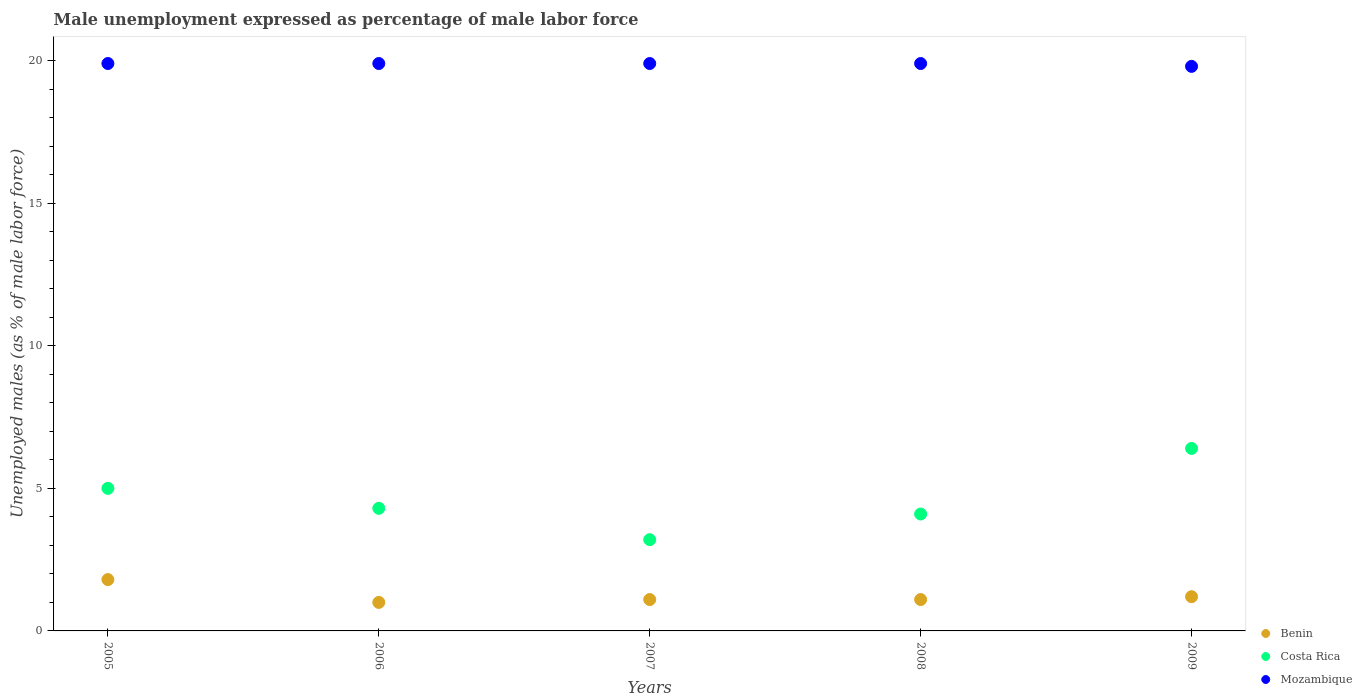How many different coloured dotlines are there?
Your answer should be very brief. 3. What is the unemployment in males in in Benin in 2009?
Your answer should be compact. 1.2. Across all years, what is the maximum unemployment in males in in Mozambique?
Your response must be concise. 19.9. In which year was the unemployment in males in in Mozambique maximum?
Your answer should be compact. 2005. What is the total unemployment in males in in Benin in the graph?
Give a very brief answer. 6.2. What is the difference between the unemployment in males in in Benin in 2005 and that in 2006?
Your response must be concise. 0.8. What is the difference between the unemployment in males in in Mozambique in 2007 and the unemployment in males in in Benin in 2009?
Keep it short and to the point. 18.7. What is the average unemployment in males in in Mozambique per year?
Keep it short and to the point. 19.88. In the year 2005, what is the difference between the unemployment in males in in Mozambique and unemployment in males in in Benin?
Provide a succinct answer. 18.1. What is the ratio of the unemployment in males in in Costa Rica in 2005 to that in 2007?
Provide a succinct answer. 1.56. What is the difference between the highest and the second highest unemployment in males in in Benin?
Give a very brief answer. 0.6. What is the difference between the highest and the lowest unemployment in males in in Mozambique?
Provide a succinct answer. 0.1. In how many years, is the unemployment in males in in Costa Rica greater than the average unemployment in males in in Costa Rica taken over all years?
Give a very brief answer. 2. Is the sum of the unemployment in males in in Benin in 2005 and 2007 greater than the maximum unemployment in males in in Mozambique across all years?
Keep it short and to the point. No. Is it the case that in every year, the sum of the unemployment in males in in Costa Rica and unemployment in males in in Benin  is greater than the unemployment in males in in Mozambique?
Your response must be concise. No. Does the unemployment in males in in Costa Rica monotonically increase over the years?
Keep it short and to the point. No. How many dotlines are there?
Keep it short and to the point. 3. How many years are there in the graph?
Your response must be concise. 5. What is the difference between two consecutive major ticks on the Y-axis?
Offer a terse response. 5. Are the values on the major ticks of Y-axis written in scientific E-notation?
Ensure brevity in your answer.  No. Does the graph contain any zero values?
Your response must be concise. No. Does the graph contain grids?
Your answer should be compact. No. How are the legend labels stacked?
Ensure brevity in your answer.  Vertical. What is the title of the graph?
Give a very brief answer. Male unemployment expressed as percentage of male labor force. Does "Uzbekistan" appear as one of the legend labels in the graph?
Your answer should be very brief. No. What is the label or title of the X-axis?
Provide a succinct answer. Years. What is the label or title of the Y-axis?
Your answer should be very brief. Unemployed males (as % of male labor force). What is the Unemployed males (as % of male labor force) in Benin in 2005?
Ensure brevity in your answer.  1.8. What is the Unemployed males (as % of male labor force) in Mozambique in 2005?
Provide a succinct answer. 19.9. What is the Unemployed males (as % of male labor force) in Benin in 2006?
Offer a terse response. 1. What is the Unemployed males (as % of male labor force) in Costa Rica in 2006?
Provide a succinct answer. 4.3. What is the Unemployed males (as % of male labor force) of Mozambique in 2006?
Your answer should be compact. 19.9. What is the Unemployed males (as % of male labor force) in Benin in 2007?
Keep it short and to the point. 1.1. What is the Unemployed males (as % of male labor force) in Costa Rica in 2007?
Your response must be concise. 3.2. What is the Unemployed males (as % of male labor force) of Mozambique in 2007?
Make the answer very short. 19.9. What is the Unemployed males (as % of male labor force) in Benin in 2008?
Ensure brevity in your answer.  1.1. What is the Unemployed males (as % of male labor force) of Costa Rica in 2008?
Give a very brief answer. 4.1. What is the Unemployed males (as % of male labor force) in Mozambique in 2008?
Provide a succinct answer. 19.9. What is the Unemployed males (as % of male labor force) of Benin in 2009?
Offer a very short reply. 1.2. What is the Unemployed males (as % of male labor force) of Costa Rica in 2009?
Offer a very short reply. 6.4. What is the Unemployed males (as % of male labor force) in Mozambique in 2009?
Offer a terse response. 19.8. Across all years, what is the maximum Unemployed males (as % of male labor force) in Benin?
Provide a short and direct response. 1.8. Across all years, what is the maximum Unemployed males (as % of male labor force) of Costa Rica?
Provide a succinct answer. 6.4. Across all years, what is the maximum Unemployed males (as % of male labor force) of Mozambique?
Offer a very short reply. 19.9. Across all years, what is the minimum Unemployed males (as % of male labor force) of Benin?
Offer a terse response. 1. Across all years, what is the minimum Unemployed males (as % of male labor force) of Costa Rica?
Offer a very short reply. 3.2. Across all years, what is the minimum Unemployed males (as % of male labor force) of Mozambique?
Your response must be concise. 19.8. What is the total Unemployed males (as % of male labor force) of Benin in the graph?
Provide a succinct answer. 6.2. What is the total Unemployed males (as % of male labor force) in Mozambique in the graph?
Offer a very short reply. 99.4. What is the difference between the Unemployed males (as % of male labor force) in Benin in 2005 and that in 2006?
Ensure brevity in your answer.  0.8. What is the difference between the Unemployed males (as % of male labor force) in Costa Rica in 2005 and that in 2006?
Make the answer very short. 0.7. What is the difference between the Unemployed males (as % of male labor force) of Mozambique in 2005 and that in 2006?
Offer a very short reply. 0. What is the difference between the Unemployed males (as % of male labor force) of Benin in 2005 and that in 2009?
Ensure brevity in your answer.  0.6. What is the difference between the Unemployed males (as % of male labor force) in Costa Rica in 2005 and that in 2009?
Keep it short and to the point. -1.4. What is the difference between the Unemployed males (as % of male labor force) of Benin in 2006 and that in 2007?
Offer a terse response. -0.1. What is the difference between the Unemployed males (as % of male labor force) in Costa Rica in 2006 and that in 2007?
Give a very brief answer. 1.1. What is the difference between the Unemployed males (as % of male labor force) of Mozambique in 2006 and that in 2007?
Give a very brief answer. 0. What is the difference between the Unemployed males (as % of male labor force) in Benin in 2006 and that in 2008?
Make the answer very short. -0.1. What is the difference between the Unemployed males (as % of male labor force) in Costa Rica in 2006 and that in 2008?
Ensure brevity in your answer.  0.2. What is the difference between the Unemployed males (as % of male labor force) of Benin in 2006 and that in 2009?
Provide a short and direct response. -0.2. What is the difference between the Unemployed males (as % of male labor force) of Costa Rica in 2006 and that in 2009?
Provide a succinct answer. -2.1. What is the difference between the Unemployed males (as % of male labor force) in Benin in 2007 and that in 2008?
Offer a terse response. 0. What is the difference between the Unemployed males (as % of male labor force) of Mozambique in 2007 and that in 2009?
Offer a very short reply. 0.1. What is the difference between the Unemployed males (as % of male labor force) in Mozambique in 2008 and that in 2009?
Offer a very short reply. 0.1. What is the difference between the Unemployed males (as % of male labor force) in Benin in 2005 and the Unemployed males (as % of male labor force) in Costa Rica in 2006?
Provide a succinct answer. -2.5. What is the difference between the Unemployed males (as % of male labor force) in Benin in 2005 and the Unemployed males (as % of male labor force) in Mozambique in 2006?
Provide a short and direct response. -18.1. What is the difference between the Unemployed males (as % of male labor force) of Costa Rica in 2005 and the Unemployed males (as % of male labor force) of Mozambique in 2006?
Your answer should be compact. -14.9. What is the difference between the Unemployed males (as % of male labor force) in Benin in 2005 and the Unemployed males (as % of male labor force) in Costa Rica in 2007?
Keep it short and to the point. -1.4. What is the difference between the Unemployed males (as % of male labor force) in Benin in 2005 and the Unemployed males (as % of male labor force) in Mozambique in 2007?
Provide a short and direct response. -18.1. What is the difference between the Unemployed males (as % of male labor force) in Costa Rica in 2005 and the Unemployed males (as % of male labor force) in Mozambique in 2007?
Offer a terse response. -14.9. What is the difference between the Unemployed males (as % of male labor force) of Benin in 2005 and the Unemployed males (as % of male labor force) of Mozambique in 2008?
Your answer should be very brief. -18.1. What is the difference between the Unemployed males (as % of male labor force) in Costa Rica in 2005 and the Unemployed males (as % of male labor force) in Mozambique in 2008?
Ensure brevity in your answer.  -14.9. What is the difference between the Unemployed males (as % of male labor force) of Benin in 2005 and the Unemployed males (as % of male labor force) of Costa Rica in 2009?
Your response must be concise. -4.6. What is the difference between the Unemployed males (as % of male labor force) of Costa Rica in 2005 and the Unemployed males (as % of male labor force) of Mozambique in 2009?
Provide a succinct answer. -14.8. What is the difference between the Unemployed males (as % of male labor force) in Benin in 2006 and the Unemployed males (as % of male labor force) in Costa Rica in 2007?
Give a very brief answer. -2.2. What is the difference between the Unemployed males (as % of male labor force) of Benin in 2006 and the Unemployed males (as % of male labor force) of Mozambique in 2007?
Ensure brevity in your answer.  -18.9. What is the difference between the Unemployed males (as % of male labor force) of Costa Rica in 2006 and the Unemployed males (as % of male labor force) of Mozambique in 2007?
Provide a short and direct response. -15.6. What is the difference between the Unemployed males (as % of male labor force) in Benin in 2006 and the Unemployed males (as % of male labor force) in Costa Rica in 2008?
Give a very brief answer. -3.1. What is the difference between the Unemployed males (as % of male labor force) of Benin in 2006 and the Unemployed males (as % of male labor force) of Mozambique in 2008?
Your answer should be very brief. -18.9. What is the difference between the Unemployed males (as % of male labor force) in Costa Rica in 2006 and the Unemployed males (as % of male labor force) in Mozambique in 2008?
Give a very brief answer. -15.6. What is the difference between the Unemployed males (as % of male labor force) of Benin in 2006 and the Unemployed males (as % of male labor force) of Mozambique in 2009?
Provide a short and direct response. -18.8. What is the difference between the Unemployed males (as % of male labor force) in Costa Rica in 2006 and the Unemployed males (as % of male labor force) in Mozambique in 2009?
Give a very brief answer. -15.5. What is the difference between the Unemployed males (as % of male labor force) of Benin in 2007 and the Unemployed males (as % of male labor force) of Costa Rica in 2008?
Ensure brevity in your answer.  -3. What is the difference between the Unemployed males (as % of male labor force) of Benin in 2007 and the Unemployed males (as % of male labor force) of Mozambique in 2008?
Your answer should be very brief. -18.8. What is the difference between the Unemployed males (as % of male labor force) in Costa Rica in 2007 and the Unemployed males (as % of male labor force) in Mozambique in 2008?
Provide a succinct answer. -16.7. What is the difference between the Unemployed males (as % of male labor force) in Benin in 2007 and the Unemployed males (as % of male labor force) in Mozambique in 2009?
Give a very brief answer. -18.7. What is the difference between the Unemployed males (as % of male labor force) of Costa Rica in 2007 and the Unemployed males (as % of male labor force) of Mozambique in 2009?
Keep it short and to the point. -16.6. What is the difference between the Unemployed males (as % of male labor force) in Benin in 2008 and the Unemployed males (as % of male labor force) in Costa Rica in 2009?
Provide a short and direct response. -5.3. What is the difference between the Unemployed males (as % of male labor force) in Benin in 2008 and the Unemployed males (as % of male labor force) in Mozambique in 2009?
Your response must be concise. -18.7. What is the difference between the Unemployed males (as % of male labor force) of Costa Rica in 2008 and the Unemployed males (as % of male labor force) of Mozambique in 2009?
Make the answer very short. -15.7. What is the average Unemployed males (as % of male labor force) of Benin per year?
Your answer should be compact. 1.24. What is the average Unemployed males (as % of male labor force) in Mozambique per year?
Offer a terse response. 19.88. In the year 2005, what is the difference between the Unemployed males (as % of male labor force) of Benin and Unemployed males (as % of male labor force) of Mozambique?
Your answer should be compact. -18.1. In the year 2005, what is the difference between the Unemployed males (as % of male labor force) of Costa Rica and Unemployed males (as % of male labor force) of Mozambique?
Your response must be concise. -14.9. In the year 2006, what is the difference between the Unemployed males (as % of male labor force) in Benin and Unemployed males (as % of male labor force) in Mozambique?
Offer a very short reply. -18.9. In the year 2006, what is the difference between the Unemployed males (as % of male labor force) of Costa Rica and Unemployed males (as % of male labor force) of Mozambique?
Offer a very short reply. -15.6. In the year 2007, what is the difference between the Unemployed males (as % of male labor force) of Benin and Unemployed males (as % of male labor force) of Costa Rica?
Provide a succinct answer. -2.1. In the year 2007, what is the difference between the Unemployed males (as % of male labor force) in Benin and Unemployed males (as % of male labor force) in Mozambique?
Your answer should be very brief. -18.8. In the year 2007, what is the difference between the Unemployed males (as % of male labor force) in Costa Rica and Unemployed males (as % of male labor force) in Mozambique?
Your answer should be very brief. -16.7. In the year 2008, what is the difference between the Unemployed males (as % of male labor force) of Benin and Unemployed males (as % of male labor force) of Costa Rica?
Provide a short and direct response. -3. In the year 2008, what is the difference between the Unemployed males (as % of male labor force) of Benin and Unemployed males (as % of male labor force) of Mozambique?
Your answer should be compact. -18.8. In the year 2008, what is the difference between the Unemployed males (as % of male labor force) in Costa Rica and Unemployed males (as % of male labor force) in Mozambique?
Give a very brief answer. -15.8. In the year 2009, what is the difference between the Unemployed males (as % of male labor force) of Benin and Unemployed males (as % of male labor force) of Costa Rica?
Provide a short and direct response. -5.2. In the year 2009, what is the difference between the Unemployed males (as % of male labor force) in Benin and Unemployed males (as % of male labor force) in Mozambique?
Make the answer very short. -18.6. In the year 2009, what is the difference between the Unemployed males (as % of male labor force) of Costa Rica and Unemployed males (as % of male labor force) of Mozambique?
Offer a very short reply. -13.4. What is the ratio of the Unemployed males (as % of male labor force) in Costa Rica in 2005 to that in 2006?
Provide a short and direct response. 1.16. What is the ratio of the Unemployed males (as % of male labor force) of Mozambique in 2005 to that in 2006?
Your answer should be compact. 1. What is the ratio of the Unemployed males (as % of male labor force) in Benin in 2005 to that in 2007?
Give a very brief answer. 1.64. What is the ratio of the Unemployed males (as % of male labor force) of Costa Rica in 2005 to that in 2007?
Give a very brief answer. 1.56. What is the ratio of the Unemployed males (as % of male labor force) in Mozambique in 2005 to that in 2007?
Offer a very short reply. 1. What is the ratio of the Unemployed males (as % of male labor force) in Benin in 2005 to that in 2008?
Make the answer very short. 1.64. What is the ratio of the Unemployed males (as % of male labor force) in Costa Rica in 2005 to that in 2008?
Offer a terse response. 1.22. What is the ratio of the Unemployed males (as % of male labor force) of Costa Rica in 2005 to that in 2009?
Make the answer very short. 0.78. What is the ratio of the Unemployed males (as % of male labor force) of Costa Rica in 2006 to that in 2007?
Offer a terse response. 1.34. What is the ratio of the Unemployed males (as % of male labor force) in Benin in 2006 to that in 2008?
Keep it short and to the point. 0.91. What is the ratio of the Unemployed males (as % of male labor force) of Costa Rica in 2006 to that in 2008?
Offer a terse response. 1.05. What is the ratio of the Unemployed males (as % of male labor force) in Benin in 2006 to that in 2009?
Provide a succinct answer. 0.83. What is the ratio of the Unemployed males (as % of male labor force) of Costa Rica in 2006 to that in 2009?
Your answer should be compact. 0.67. What is the ratio of the Unemployed males (as % of male labor force) of Costa Rica in 2007 to that in 2008?
Keep it short and to the point. 0.78. What is the ratio of the Unemployed males (as % of male labor force) in Benin in 2007 to that in 2009?
Offer a very short reply. 0.92. What is the ratio of the Unemployed males (as % of male labor force) in Costa Rica in 2007 to that in 2009?
Make the answer very short. 0.5. What is the ratio of the Unemployed males (as % of male labor force) in Mozambique in 2007 to that in 2009?
Keep it short and to the point. 1.01. What is the ratio of the Unemployed males (as % of male labor force) in Costa Rica in 2008 to that in 2009?
Make the answer very short. 0.64. What is the difference between the highest and the second highest Unemployed males (as % of male labor force) in Benin?
Keep it short and to the point. 0.6. 